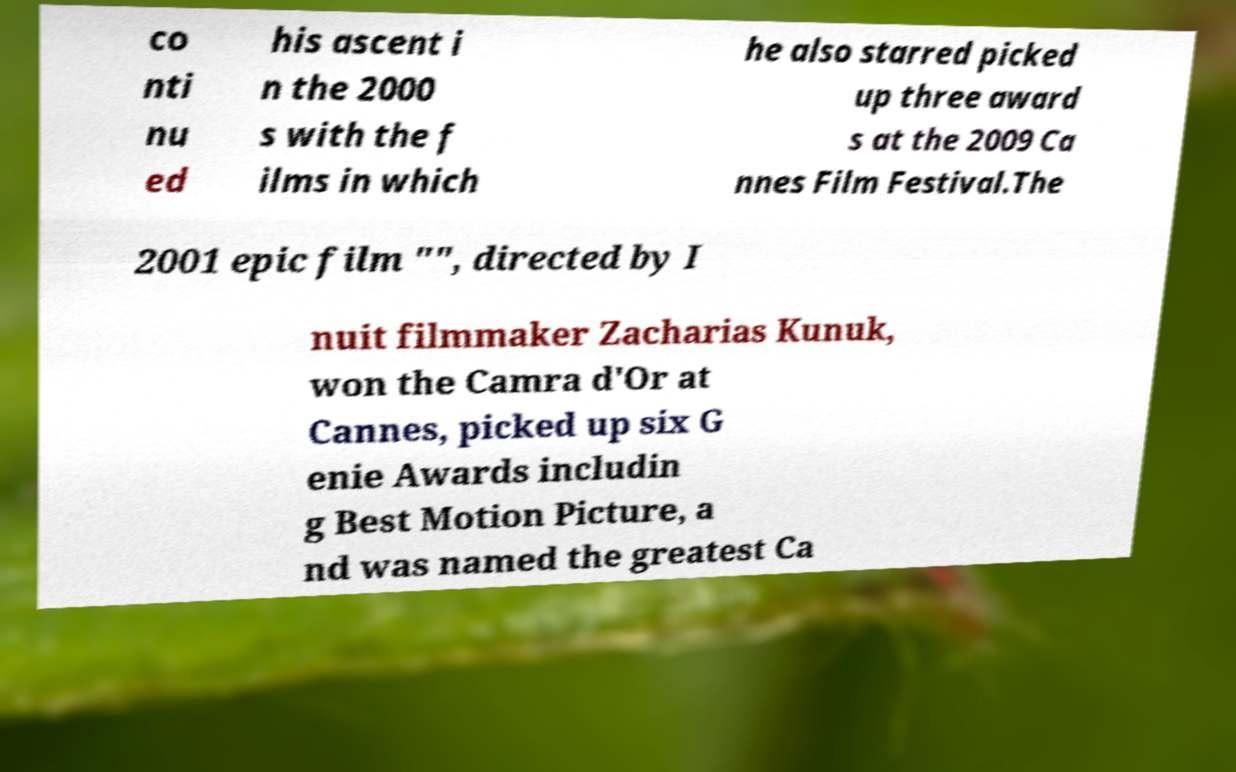Can you read and provide the text displayed in the image?This photo seems to have some interesting text. Can you extract and type it out for me? co nti nu ed his ascent i n the 2000 s with the f ilms in which he also starred picked up three award s at the 2009 Ca nnes Film Festival.The 2001 epic film "", directed by I nuit filmmaker Zacharias Kunuk, won the Camra d'Or at Cannes, picked up six G enie Awards includin g Best Motion Picture, a nd was named the greatest Ca 